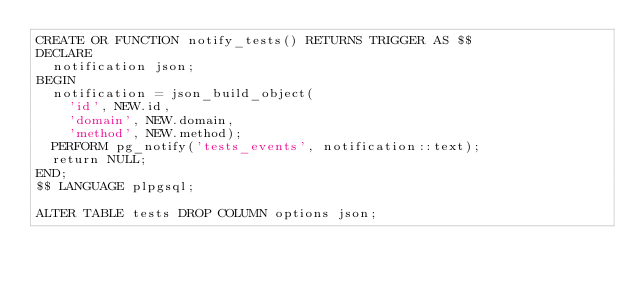<code> <loc_0><loc_0><loc_500><loc_500><_SQL_>CREATE OR FUNCTION notify_tests() RETURNS TRIGGER AS $$
DECLARE
  notification json;
BEGIN
  notification = json_build_object(
    'id', NEW.id,
    'domain', NEW.domain,
    'method', NEW.method);
  PERFORM pg_notify('tests_events', notification::text);
  return NULL;
END;
$$ LANGUAGE plpgsql;

ALTER TABLE tests DROP COLUMN options json;</code> 